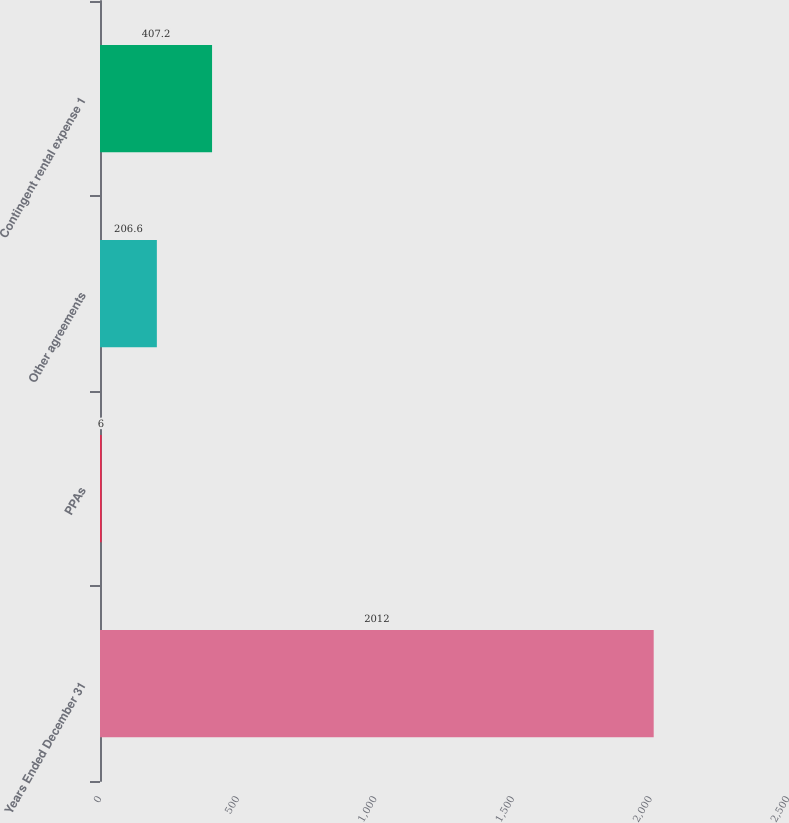Convert chart. <chart><loc_0><loc_0><loc_500><loc_500><bar_chart><fcel>Years Ended December 31<fcel>PPAs<fcel>Other agreements<fcel>Contingent rental expense 1<nl><fcel>2012<fcel>6<fcel>206.6<fcel>407.2<nl></chart> 